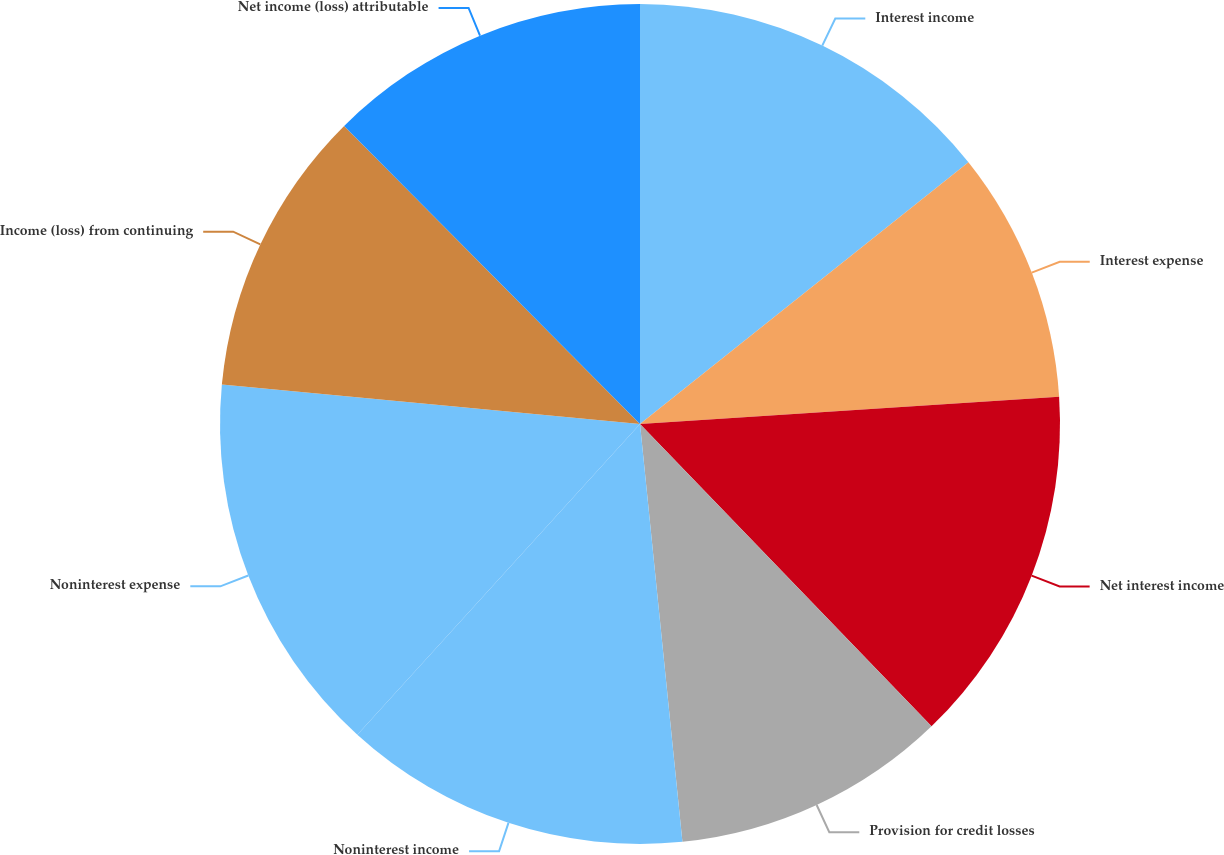Convert chart. <chart><loc_0><loc_0><loc_500><loc_500><pie_chart><fcel>Interest income<fcel>Interest expense<fcel>Net interest income<fcel>Provision for credit losses<fcel>Noninterest income<fcel>Noninterest expense<fcel>Income (loss) from continuing<fcel>Net income (loss) attributable<nl><fcel>14.29%<fcel>9.68%<fcel>13.82%<fcel>10.6%<fcel>13.36%<fcel>14.75%<fcel>11.06%<fcel>12.44%<nl></chart> 